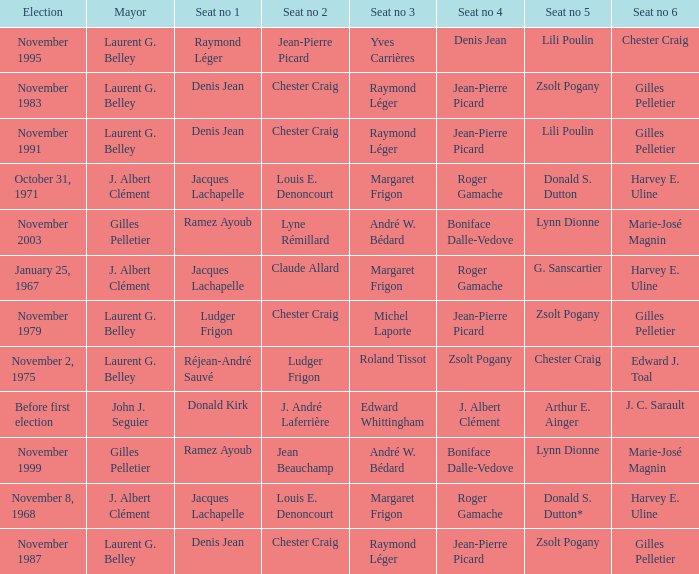Who is seat no 1 when the mayor was john j. seguier Donald Kirk. Would you mind parsing the complete table? {'header': ['Election', 'Mayor', 'Seat no 1', 'Seat no 2', 'Seat no 3', 'Seat no 4', 'Seat no 5', 'Seat no 6'], 'rows': [['November 1995', 'Laurent G. Belley', 'Raymond Léger', 'Jean-Pierre Picard', 'Yves Carrières', 'Denis Jean', 'Lili Poulin', 'Chester Craig'], ['November 1983', 'Laurent G. Belley', 'Denis Jean', 'Chester Craig', 'Raymond Léger', 'Jean-Pierre Picard', 'Zsolt Pogany', 'Gilles Pelletier'], ['November 1991', 'Laurent G. Belley', 'Denis Jean', 'Chester Craig', 'Raymond Léger', 'Jean-Pierre Picard', 'Lili Poulin', 'Gilles Pelletier'], ['October 31, 1971', 'J. Albert Clément', 'Jacques Lachapelle', 'Louis E. Denoncourt', 'Margaret Frigon', 'Roger Gamache', 'Donald S. Dutton', 'Harvey E. Uline'], ['November 2003', 'Gilles Pelletier', 'Ramez Ayoub', 'Lyne Rémillard', 'André W. Bédard', 'Boniface Dalle-Vedove', 'Lynn Dionne', 'Marie-José Magnin'], ['January 25, 1967', 'J. Albert Clément', 'Jacques Lachapelle', 'Claude Allard', 'Margaret Frigon', 'Roger Gamache', 'G. Sanscartier', 'Harvey E. Uline'], ['November 1979', 'Laurent G. Belley', 'Ludger Frigon', 'Chester Craig', 'Michel Laporte', 'Jean-Pierre Picard', 'Zsolt Pogany', 'Gilles Pelletier'], ['November 2, 1975', 'Laurent G. Belley', 'Réjean-André Sauvé', 'Ludger Frigon', 'Roland Tissot', 'Zsolt Pogany', 'Chester Craig', 'Edward J. Toal'], ['Before first election', 'John J. Seguier', 'Donald Kirk', 'J. André Laferrière', 'Edward Whittingham', 'J. Albert Clément', 'Arthur E. Ainger', 'J. C. Sarault'], ['November 1999', 'Gilles Pelletier', 'Ramez Ayoub', 'Jean Beauchamp', 'André W. Bédard', 'Boniface Dalle-Vedove', 'Lynn Dionne', 'Marie-José Magnin'], ['November 8, 1968', 'J. Albert Clément', 'Jacques Lachapelle', 'Louis E. Denoncourt', 'Margaret Frigon', 'Roger Gamache', 'Donald S. Dutton*', 'Harvey E. Uline'], ['November 1987', 'Laurent G. Belley', 'Denis Jean', 'Chester Craig', 'Raymond Léger', 'Jean-Pierre Picard', 'Zsolt Pogany', 'Gilles Pelletier']]} 